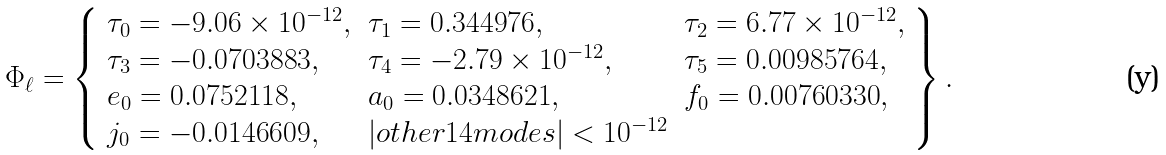<formula> <loc_0><loc_0><loc_500><loc_500>\Phi _ { \ell } = \left \{ \begin{array} { l l l } { { \tau _ { 0 } = - 9 . 0 6 \times 1 0 ^ { - 1 2 } , } } & { { \tau _ { 1 } = 0 . 3 4 4 9 7 6 , } } & { { \tau _ { 2 } = 6 . 7 7 \times 1 0 ^ { - 1 2 } , } } \\ { { \tau _ { 3 } = - 0 . 0 7 0 3 8 8 3 , } } & { { \tau _ { 4 } = - 2 . 7 9 \times 1 0 ^ { - 1 2 } , } } & { { \tau _ { 5 } = 0 . 0 0 9 8 5 7 6 4 , } } \\ { { e _ { 0 } = 0 . 0 7 5 2 1 1 8 , } } & { { a _ { 0 } = 0 . 0 3 4 8 6 2 1 , } } & { { f _ { 0 } = 0 . 0 0 7 6 0 3 3 0 , } } \\ { { j _ { 0 } = - 0 . 0 1 4 6 6 0 9 , } } & { { | o t h e r 1 4 m o d e s | < 1 0 ^ { - 1 2 } } } \end{array} \right \} .</formula> 